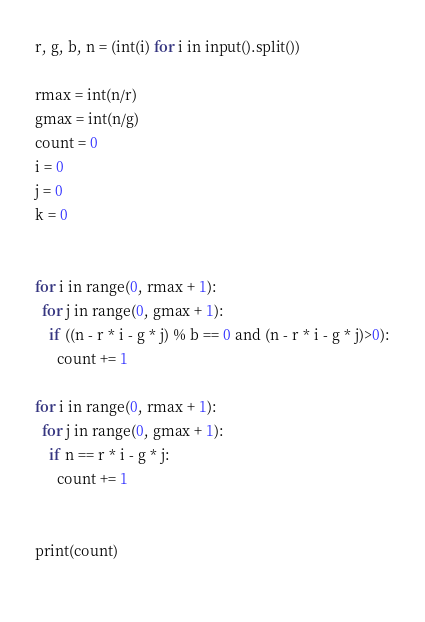<code> <loc_0><loc_0><loc_500><loc_500><_Python_>r, g, b, n = (int(i) for i in input().split())  

rmax = int(n/r)
gmax = int(n/g)
count = 0
i = 0
j = 0
k = 0


for i in range(0, rmax + 1):
  for j in range(0, gmax + 1):
    if ((n - r * i - g * j) % b == 0 and (n - r * i - g * j)>0):
      count += 1

for i in range(0, rmax + 1):
  for j in range(0, gmax + 1):
    if n == r * i - g * j:
      count += 1
      
  
print(count)
  
</code> 